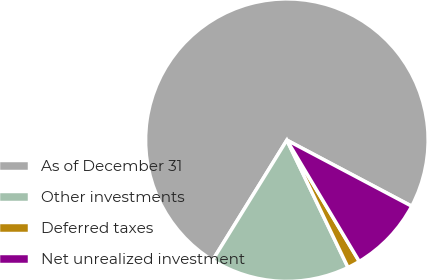Convert chart. <chart><loc_0><loc_0><loc_500><loc_500><pie_chart><fcel>As of December 31<fcel>Other investments<fcel>Deferred taxes<fcel>Net unrealized investment<nl><fcel>73.94%<fcel>15.94%<fcel>1.44%<fcel>8.69%<nl></chart> 